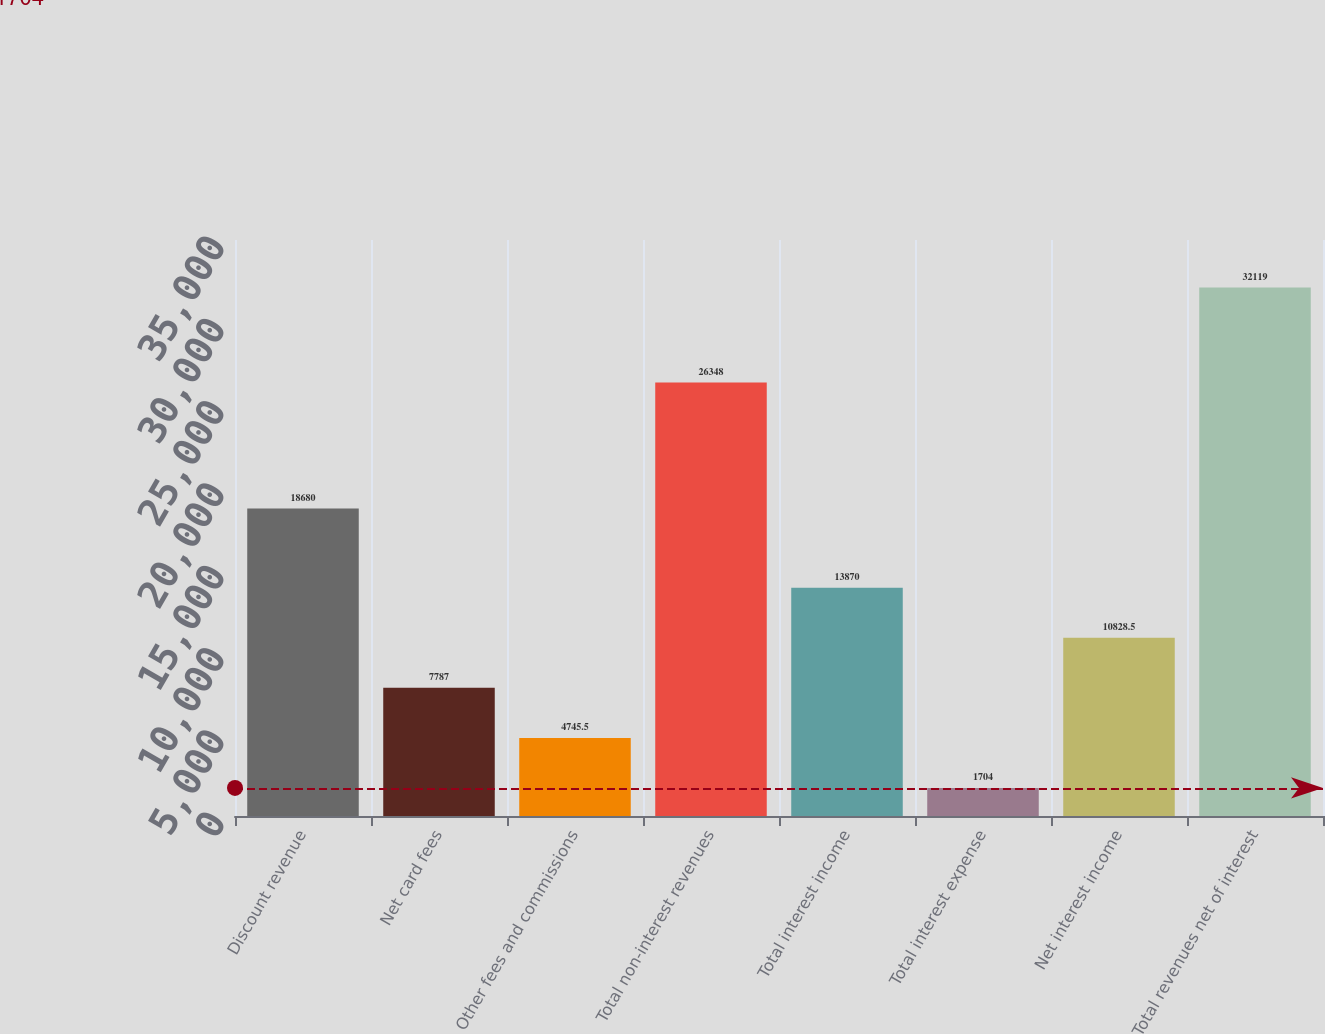Convert chart to OTSL. <chart><loc_0><loc_0><loc_500><loc_500><bar_chart><fcel>Discount revenue<fcel>Net card fees<fcel>Other fees and commissions<fcel>Total non-interest revenues<fcel>Total interest income<fcel>Total interest expense<fcel>Net interest income<fcel>Total revenues net of interest<nl><fcel>18680<fcel>7787<fcel>4745.5<fcel>26348<fcel>13870<fcel>1704<fcel>10828.5<fcel>32119<nl></chart> 